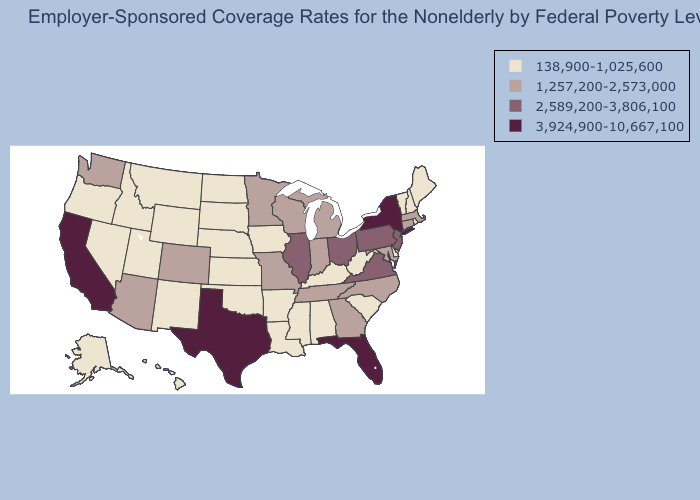Name the states that have a value in the range 3,924,900-10,667,100?
Write a very short answer. California, Florida, New York, Texas. Which states have the lowest value in the USA?
Short answer required. Alabama, Alaska, Arkansas, Delaware, Hawaii, Idaho, Iowa, Kansas, Kentucky, Louisiana, Maine, Mississippi, Montana, Nebraska, Nevada, New Hampshire, New Mexico, North Dakota, Oklahoma, Oregon, Rhode Island, South Carolina, South Dakota, Utah, Vermont, West Virginia, Wyoming. Among the states that border New Jersey , which have the highest value?
Give a very brief answer. New York. Among the states that border Indiana , does Kentucky have the lowest value?
Answer briefly. Yes. Which states have the lowest value in the USA?
Keep it brief. Alabama, Alaska, Arkansas, Delaware, Hawaii, Idaho, Iowa, Kansas, Kentucky, Louisiana, Maine, Mississippi, Montana, Nebraska, Nevada, New Hampshire, New Mexico, North Dakota, Oklahoma, Oregon, Rhode Island, South Carolina, South Dakota, Utah, Vermont, West Virginia, Wyoming. Which states have the lowest value in the Northeast?
Be succinct. Maine, New Hampshire, Rhode Island, Vermont. Among the states that border Nevada , which have the lowest value?
Be succinct. Idaho, Oregon, Utah. Does the map have missing data?
Answer briefly. No. What is the highest value in the Northeast ?
Quick response, please. 3,924,900-10,667,100. What is the lowest value in the USA?
Give a very brief answer. 138,900-1,025,600. What is the highest value in the USA?
Keep it brief. 3,924,900-10,667,100. Does Wisconsin have a higher value than Delaware?
Quick response, please. Yes. Does Hawaii have a higher value than New York?
Be succinct. No. Name the states that have a value in the range 138,900-1,025,600?
Short answer required. Alabama, Alaska, Arkansas, Delaware, Hawaii, Idaho, Iowa, Kansas, Kentucky, Louisiana, Maine, Mississippi, Montana, Nebraska, Nevada, New Hampshire, New Mexico, North Dakota, Oklahoma, Oregon, Rhode Island, South Carolina, South Dakota, Utah, Vermont, West Virginia, Wyoming. What is the lowest value in the USA?
Be succinct. 138,900-1,025,600. 